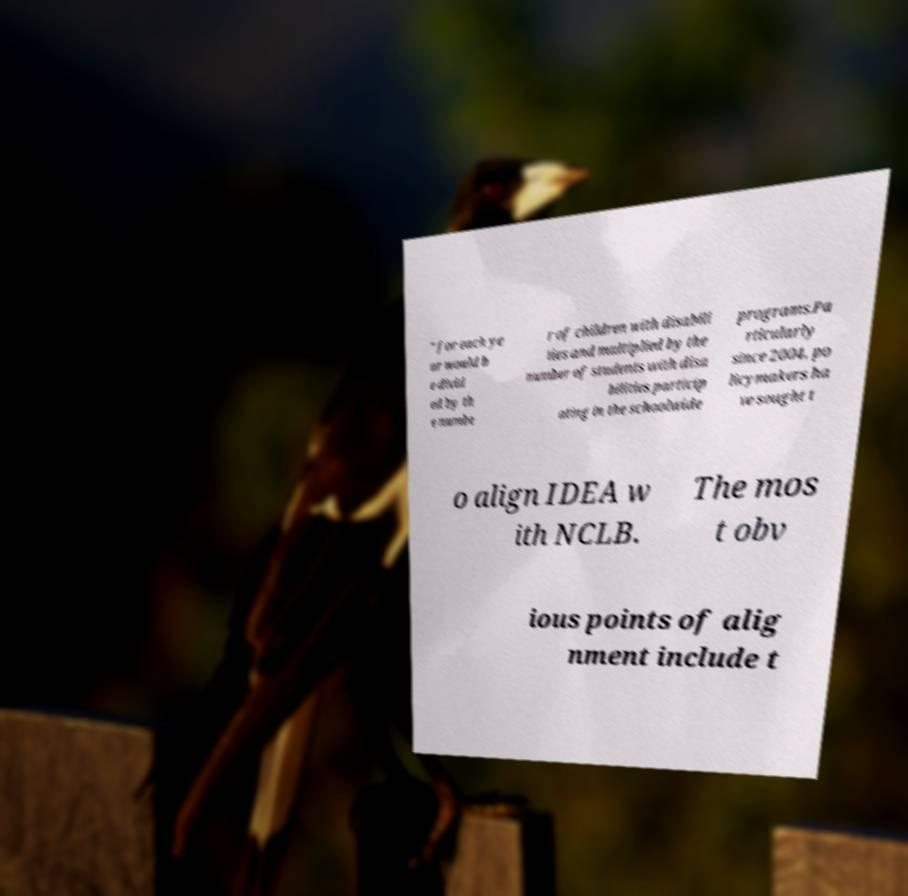What messages or text are displayed in this image? I need them in a readable, typed format. " for each ye ar would b e divid ed by th e numbe r of children with disabili ties and multiplied by the number of students with disa bilities particip ating in the schoolwide programs.Pa rticularly since 2004, po licymakers ha ve sought t o align IDEA w ith NCLB. The mos t obv ious points of alig nment include t 